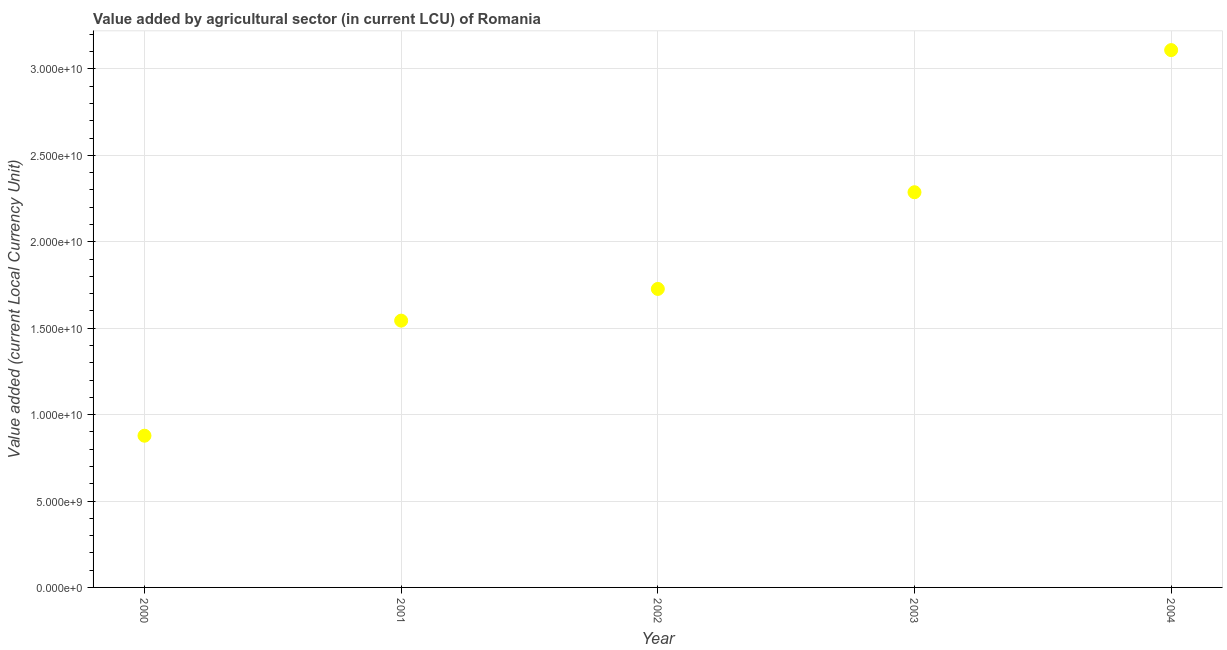What is the value added by agriculture sector in 2003?
Your response must be concise. 2.29e+1. Across all years, what is the maximum value added by agriculture sector?
Your response must be concise. 3.11e+1. Across all years, what is the minimum value added by agriculture sector?
Provide a succinct answer. 8.78e+09. In which year was the value added by agriculture sector minimum?
Keep it short and to the point. 2000. What is the sum of the value added by agriculture sector?
Your answer should be compact. 9.54e+1. What is the difference between the value added by agriculture sector in 2002 and 2003?
Provide a short and direct response. -5.59e+09. What is the average value added by agriculture sector per year?
Keep it short and to the point. 1.91e+1. What is the median value added by agriculture sector?
Keep it short and to the point. 1.73e+1. In how many years, is the value added by agriculture sector greater than 3000000000 LCU?
Give a very brief answer. 5. Do a majority of the years between 2001 and 2000 (inclusive) have value added by agriculture sector greater than 31000000000 LCU?
Offer a terse response. No. What is the ratio of the value added by agriculture sector in 2000 to that in 2003?
Provide a succinct answer. 0.38. What is the difference between the highest and the second highest value added by agriculture sector?
Offer a terse response. 8.22e+09. What is the difference between the highest and the lowest value added by agriculture sector?
Offer a very short reply. 2.23e+1. Does the graph contain any zero values?
Your response must be concise. No. What is the title of the graph?
Make the answer very short. Value added by agricultural sector (in current LCU) of Romania. What is the label or title of the X-axis?
Provide a succinct answer. Year. What is the label or title of the Y-axis?
Your response must be concise. Value added (current Local Currency Unit). What is the Value added (current Local Currency Unit) in 2000?
Your answer should be compact. 8.78e+09. What is the Value added (current Local Currency Unit) in 2001?
Provide a succinct answer. 1.54e+1. What is the Value added (current Local Currency Unit) in 2002?
Offer a terse response. 1.73e+1. What is the Value added (current Local Currency Unit) in 2003?
Your response must be concise. 2.29e+1. What is the Value added (current Local Currency Unit) in 2004?
Keep it short and to the point. 3.11e+1. What is the difference between the Value added (current Local Currency Unit) in 2000 and 2001?
Offer a terse response. -6.66e+09. What is the difference between the Value added (current Local Currency Unit) in 2000 and 2002?
Offer a terse response. -8.49e+09. What is the difference between the Value added (current Local Currency Unit) in 2000 and 2003?
Offer a terse response. -1.41e+1. What is the difference between the Value added (current Local Currency Unit) in 2000 and 2004?
Offer a very short reply. -2.23e+1. What is the difference between the Value added (current Local Currency Unit) in 2001 and 2002?
Your answer should be compact. -1.83e+09. What is the difference between the Value added (current Local Currency Unit) in 2001 and 2003?
Provide a short and direct response. -7.43e+09. What is the difference between the Value added (current Local Currency Unit) in 2001 and 2004?
Offer a very short reply. -1.57e+1. What is the difference between the Value added (current Local Currency Unit) in 2002 and 2003?
Your response must be concise. -5.59e+09. What is the difference between the Value added (current Local Currency Unit) in 2002 and 2004?
Provide a succinct answer. -1.38e+1. What is the difference between the Value added (current Local Currency Unit) in 2003 and 2004?
Keep it short and to the point. -8.22e+09. What is the ratio of the Value added (current Local Currency Unit) in 2000 to that in 2001?
Give a very brief answer. 0.57. What is the ratio of the Value added (current Local Currency Unit) in 2000 to that in 2002?
Keep it short and to the point. 0.51. What is the ratio of the Value added (current Local Currency Unit) in 2000 to that in 2003?
Provide a succinct answer. 0.38. What is the ratio of the Value added (current Local Currency Unit) in 2000 to that in 2004?
Offer a very short reply. 0.28. What is the ratio of the Value added (current Local Currency Unit) in 2001 to that in 2002?
Make the answer very short. 0.89. What is the ratio of the Value added (current Local Currency Unit) in 2001 to that in 2003?
Your answer should be compact. 0.68. What is the ratio of the Value added (current Local Currency Unit) in 2001 to that in 2004?
Give a very brief answer. 0.5. What is the ratio of the Value added (current Local Currency Unit) in 2002 to that in 2003?
Your answer should be very brief. 0.76. What is the ratio of the Value added (current Local Currency Unit) in 2002 to that in 2004?
Offer a very short reply. 0.56. What is the ratio of the Value added (current Local Currency Unit) in 2003 to that in 2004?
Provide a short and direct response. 0.73. 